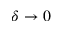<formula> <loc_0><loc_0><loc_500><loc_500>\delta \rightarrow 0</formula> 